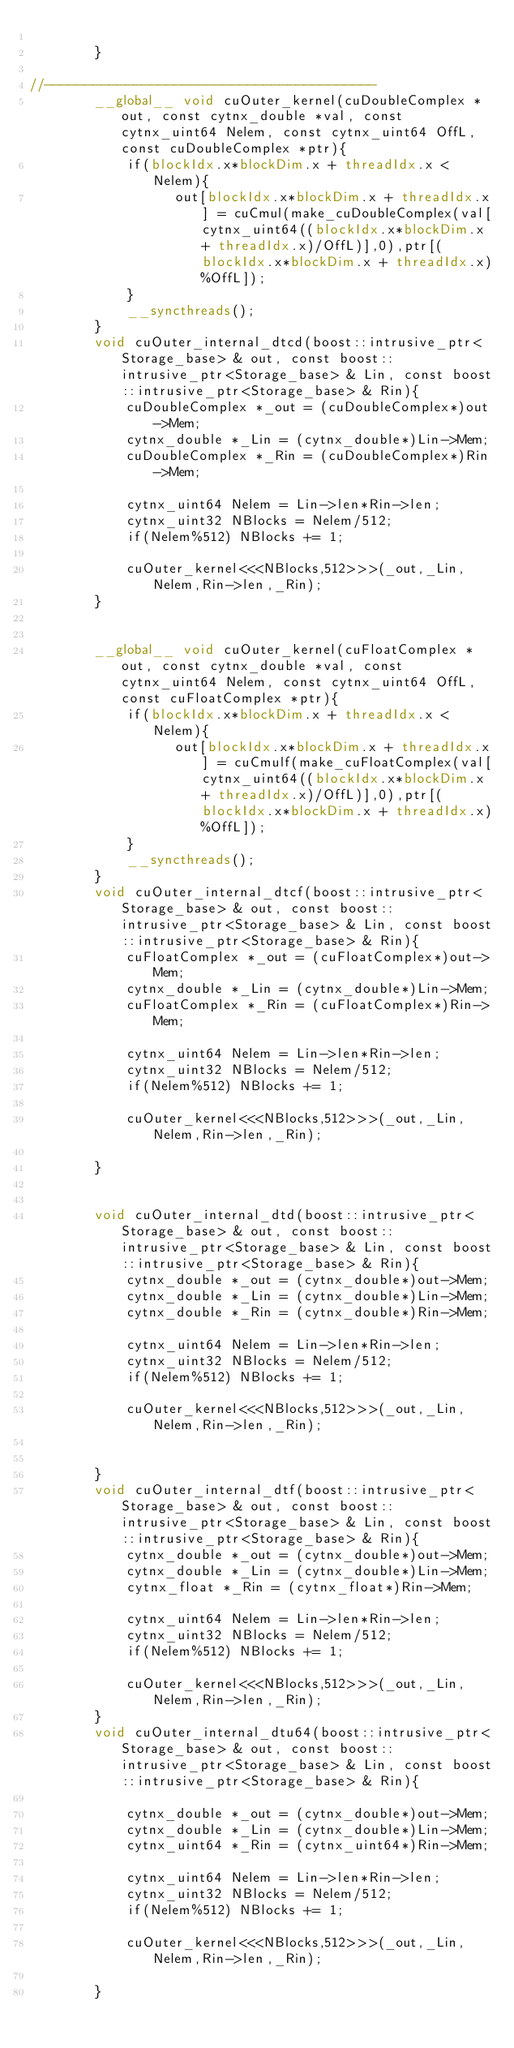<code> <loc_0><loc_0><loc_500><loc_500><_Cuda_>
        }        

//-----------------------------------------
        __global__ void cuOuter_kernel(cuDoubleComplex *out, const cytnx_double *val, const cytnx_uint64 Nelem, const cytnx_uint64 OffL,const cuDoubleComplex *ptr){
            if(blockIdx.x*blockDim.x + threadIdx.x < Nelem){                                                
                  out[blockIdx.x*blockDim.x + threadIdx.x] = cuCmul(make_cuDoubleComplex(val[cytnx_uint64((blockIdx.x*blockDim.x + threadIdx.x)/OffL)],0),ptr[(blockIdx.x*blockDim.x + threadIdx.x)%OffL]);
            }
            __syncthreads();
        }
        void cuOuter_internal_dtcd(boost::intrusive_ptr<Storage_base> & out, const boost::intrusive_ptr<Storage_base> & Lin, const boost::intrusive_ptr<Storage_base> & Rin){
            cuDoubleComplex *_out = (cuDoubleComplex*)out->Mem;
            cytnx_double *_Lin = (cytnx_double*)Lin->Mem;
            cuDoubleComplex *_Rin = (cuDoubleComplex*)Rin->Mem;

            cytnx_uint64 Nelem = Lin->len*Rin->len;
            cytnx_uint32 NBlocks = Nelem/512;
            if(Nelem%512) NBlocks += 1;
                
            cuOuter_kernel<<<NBlocks,512>>>(_out,_Lin,Nelem,Rin->len,_Rin);
        }


        __global__ void cuOuter_kernel(cuFloatComplex *out, const cytnx_double *val, const cytnx_uint64 Nelem, const cytnx_uint64 OffL,const cuFloatComplex *ptr){
            if(blockIdx.x*blockDim.x + threadIdx.x < Nelem){                                                
                  out[blockIdx.x*blockDim.x + threadIdx.x] = cuCmulf(make_cuFloatComplex(val[cytnx_uint64((blockIdx.x*blockDim.x + threadIdx.x)/OffL)],0),ptr[(blockIdx.x*blockDim.x + threadIdx.x)%OffL]);
            }
            __syncthreads();
        }
        void cuOuter_internal_dtcf(boost::intrusive_ptr<Storage_base> & out, const boost::intrusive_ptr<Storage_base> & Lin, const boost::intrusive_ptr<Storage_base> & Rin){
            cuFloatComplex *_out = (cuFloatComplex*)out->Mem;
            cytnx_double *_Lin = (cytnx_double*)Lin->Mem;
            cuFloatComplex *_Rin = (cuFloatComplex*)Rin->Mem;

            cytnx_uint64 Nelem = Lin->len*Rin->len;
            cytnx_uint32 NBlocks = Nelem/512;
            if(Nelem%512) NBlocks += 1;
                
            cuOuter_kernel<<<NBlocks,512>>>(_out,_Lin,Nelem,Rin->len,_Rin);

        }


        void cuOuter_internal_dtd(boost::intrusive_ptr<Storage_base> & out, const boost::intrusive_ptr<Storage_base> & Lin, const boost::intrusive_ptr<Storage_base> & Rin){
            cytnx_double *_out = (cytnx_double*)out->Mem;
            cytnx_double *_Lin = (cytnx_double*)Lin->Mem;
            cytnx_double *_Rin = (cytnx_double*)Rin->Mem;

            cytnx_uint64 Nelem = Lin->len*Rin->len;
            cytnx_uint32 NBlocks = Nelem/512;
            if(Nelem%512) NBlocks += 1;
                
            cuOuter_kernel<<<NBlocks,512>>>(_out,_Lin,Nelem,Rin->len,_Rin);


        }
        void cuOuter_internal_dtf(boost::intrusive_ptr<Storage_base> & out, const boost::intrusive_ptr<Storage_base> & Lin, const boost::intrusive_ptr<Storage_base> & Rin){
            cytnx_double *_out = (cytnx_double*)out->Mem;
            cytnx_double *_Lin = (cytnx_double*)Lin->Mem;
            cytnx_float *_Rin = (cytnx_float*)Rin->Mem;

            cytnx_uint64 Nelem = Lin->len*Rin->len;
            cytnx_uint32 NBlocks = Nelem/512;
            if(Nelem%512) NBlocks += 1;
                
            cuOuter_kernel<<<NBlocks,512>>>(_out,_Lin,Nelem,Rin->len,_Rin);
        }
        void cuOuter_internal_dtu64(boost::intrusive_ptr<Storage_base> & out, const boost::intrusive_ptr<Storage_base> & Lin, const boost::intrusive_ptr<Storage_base> & Rin){

            cytnx_double *_out = (cytnx_double*)out->Mem;
            cytnx_double *_Lin = (cytnx_double*)Lin->Mem;
            cytnx_uint64 *_Rin = (cytnx_uint64*)Rin->Mem;

            cytnx_uint64 Nelem = Lin->len*Rin->len;
            cytnx_uint32 NBlocks = Nelem/512;
            if(Nelem%512) NBlocks += 1;
                
            cuOuter_kernel<<<NBlocks,512>>>(_out,_Lin,Nelem,Rin->len,_Rin);

        }</code> 